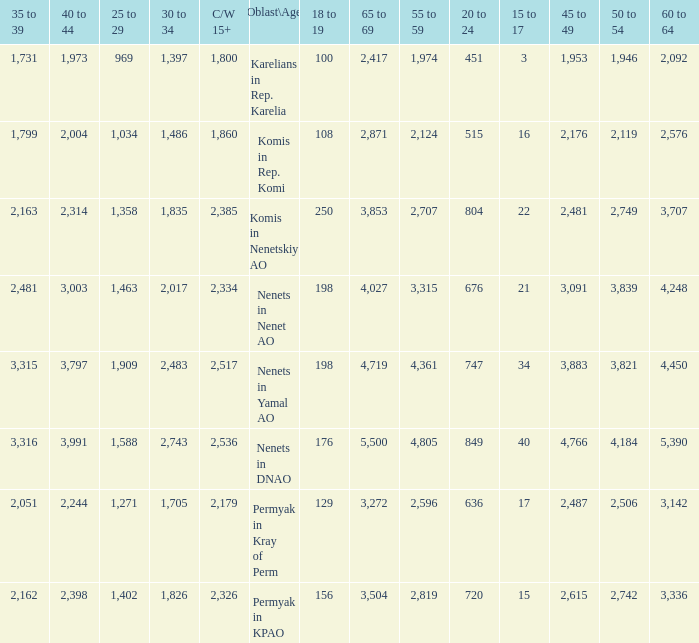What is the number of 40 to 44 when the 50 to 54 is less than 4,184, and the 15 to 17 is less than 3? 0.0. 